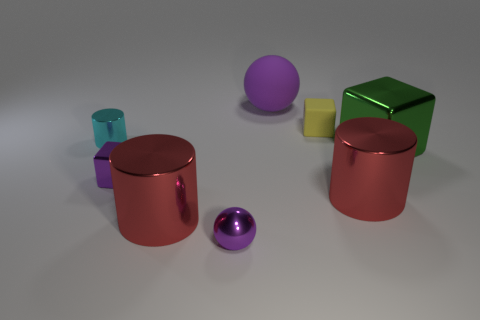There is a purple metallic thing that is to the right of the small block that is in front of the cyan thing; are there any objects to the right of it? If we are referring to the purple spherical object to the right of the small yellow block, then no, there are no objects immediately to its right; there is empty space there. However, to the far right, there is a green cube and a red cylindrical object at a distance. 